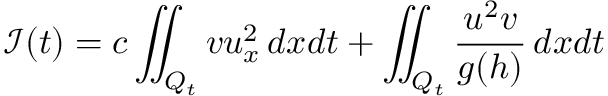<formula> <loc_0><loc_0><loc_500><loc_500>\mathcal { I } ( t ) = c \iint _ { Q _ { t } } { v u _ { x } ^ { 2 } \, d x d t } + \iint _ { Q _ { t } } { \frac { u ^ { 2 } v } { g ( h ) } \, d x d t }</formula> 